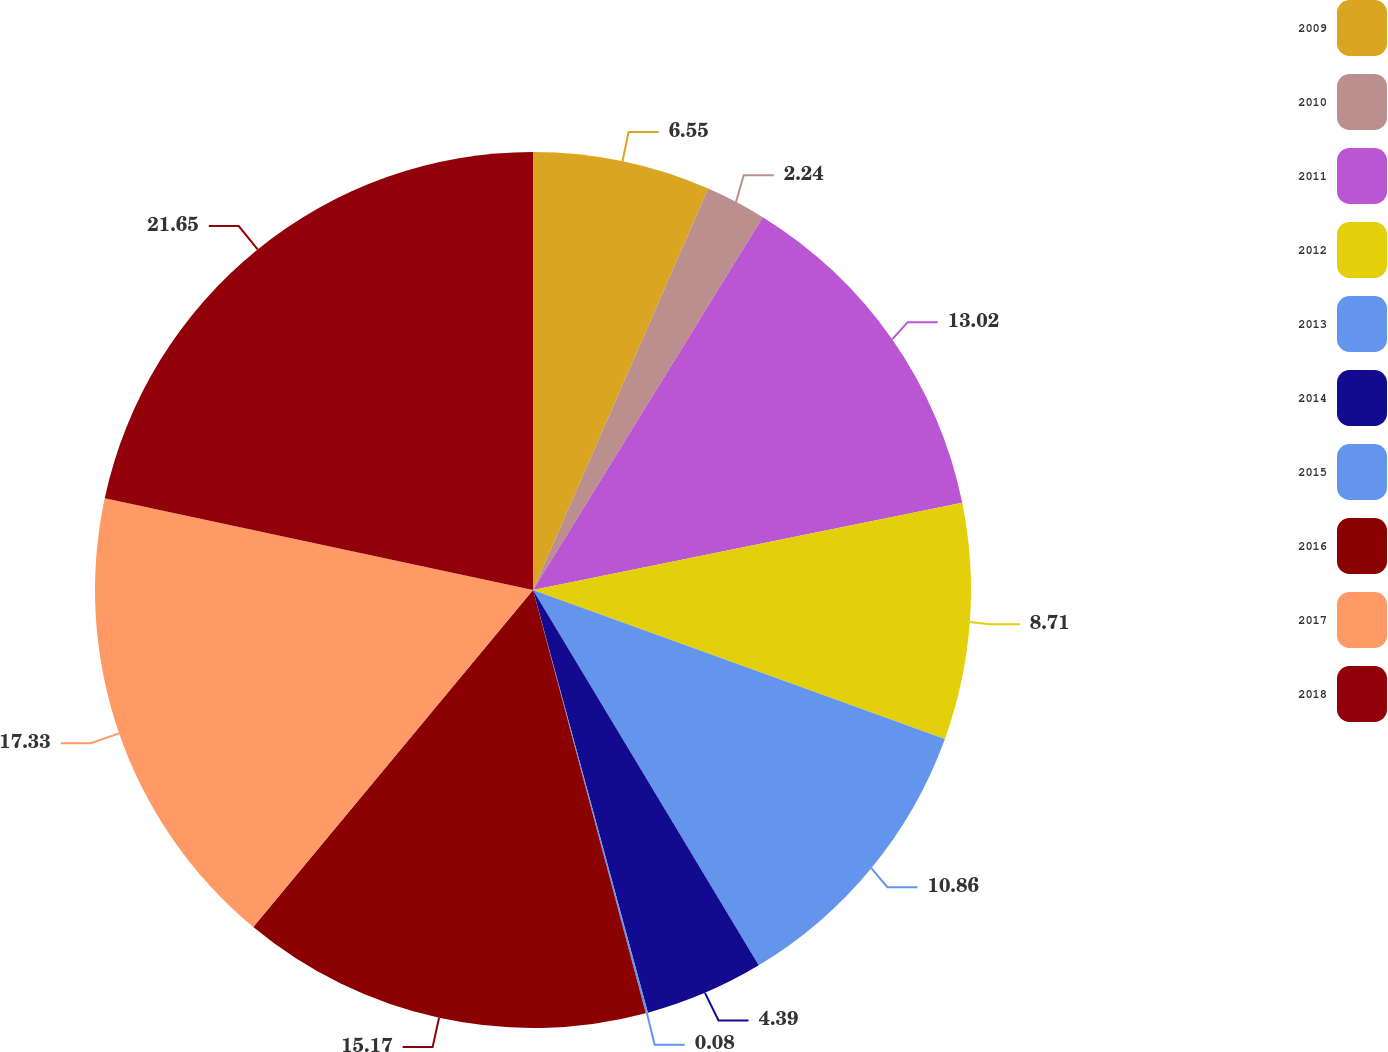Convert chart to OTSL. <chart><loc_0><loc_0><loc_500><loc_500><pie_chart><fcel>2009<fcel>2010<fcel>2011<fcel>2012<fcel>2013<fcel>2014<fcel>2015<fcel>2016<fcel>2017<fcel>2018<nl><fcel>6.55%<fcel>2.24%<fcel>13.02%<fcel>8.71%<fcel>10.86%<fcel>4.39%<fcel>0.08%<fcel>15.17%<fcel>17.33%<fcel>21.64%<nl></chart> 